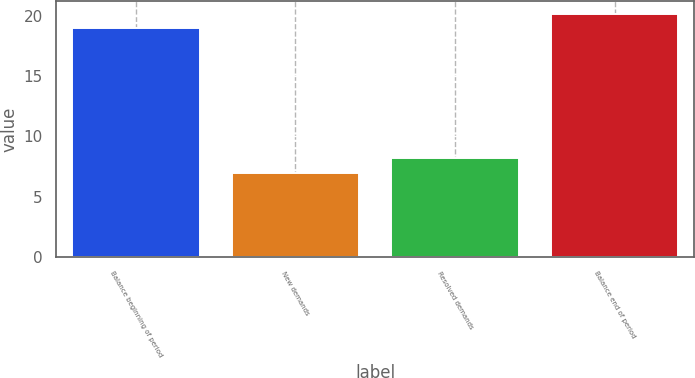<chart> <loc_0><loc_0><loc_500><loc_500><bar_chart><fcel>Balance beginning of period<fcel>New demands<fcel>Resolved demands<fcel>Balance end of period<nl><fcel>19<fcel>7<fcel>8.2<fcel>20.2<nl></chart> 